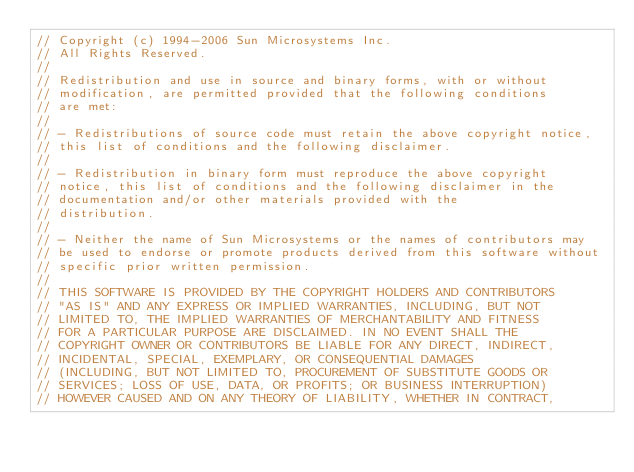Convert code to text. <code><loc_0><loc_0><loc_500><loc_500><_C++_>// Copyright (c) 1994-2006 Sun Microsystems Inc.
// All Rights Reserved.
//
// Redistribution and use in source and binary forms, with or without
// modification, are permitted provided that the following conditions
// are met:
//
// - Redistributions of source code must retain the above copyright notice,
// this list of conditions and the following disclaimer.
//
// - Redistribution in binary form must reproduce the above copyright
// notice, this list of conditions and the following disclaimer in the
// documentation and/or other materials provided with the
// distribution.
//
// - Neither the name of Sun Microsystems or the names of contributors may
// be used to endorse or promote products derived from this software without
// specific prior written permission.
//
// THIS SOFTWARE IS PROVIDED BY THE COPYRIGHT HOLDERS AND CONTRIBUTORS
// "AS IS" AND ANY EXPRESS OR IMPLIED WARRANTIES, INCLUDING, BUT NOT
// LIMITED TO, THE IMPLIED WARRANTIES OF MERCHANTABILITY AND FITNESS
// FOR A PARTICULAR PURPOSE ARE DISCLAIMED. IN NO EVENT SHALL THE
// COPYRIGHT OWNER OR CONTRIBUTORS BE LIABLE FOR ANY DIRECT, INDIRECT,
// INCIDENTAL, SPECIAL, EXEMPLARY, OR CONSEQUENTIAL DAMAGES
// (INCLUDING, BUT NOT LIMITED TO, PROCUREMENT OF SUBSTITUTE GOODS OR
// SERVICES; LOSS OF USE, DATA, OR PROFITS; OR BUSINESS INTERRUPTION)
// HOWEVER CAUSED AND ON ANY THEORY OF LIABILITY, WHETHER IN CONTRACT,</code> 